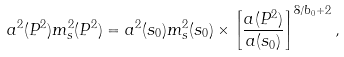Convert formula to latex. <formula><loc_0><loc_0><loc_500><loc_500>a ^ { 2 } ( P ^ { 2 } ) m _ { s } ^ { 2 } ( P ^ { 2 } ) = a ^ { 2 } ( s _ { 0 } ) m _ { s } ^ { 2 } ( s _ { 0 } ) \times \left [ \frac { a ( P ^ { 2 } ) } { a ( s _ { 0 } ) } \right ] ^ { 8 / b _ { 0 } + 2 } ,</formula> 